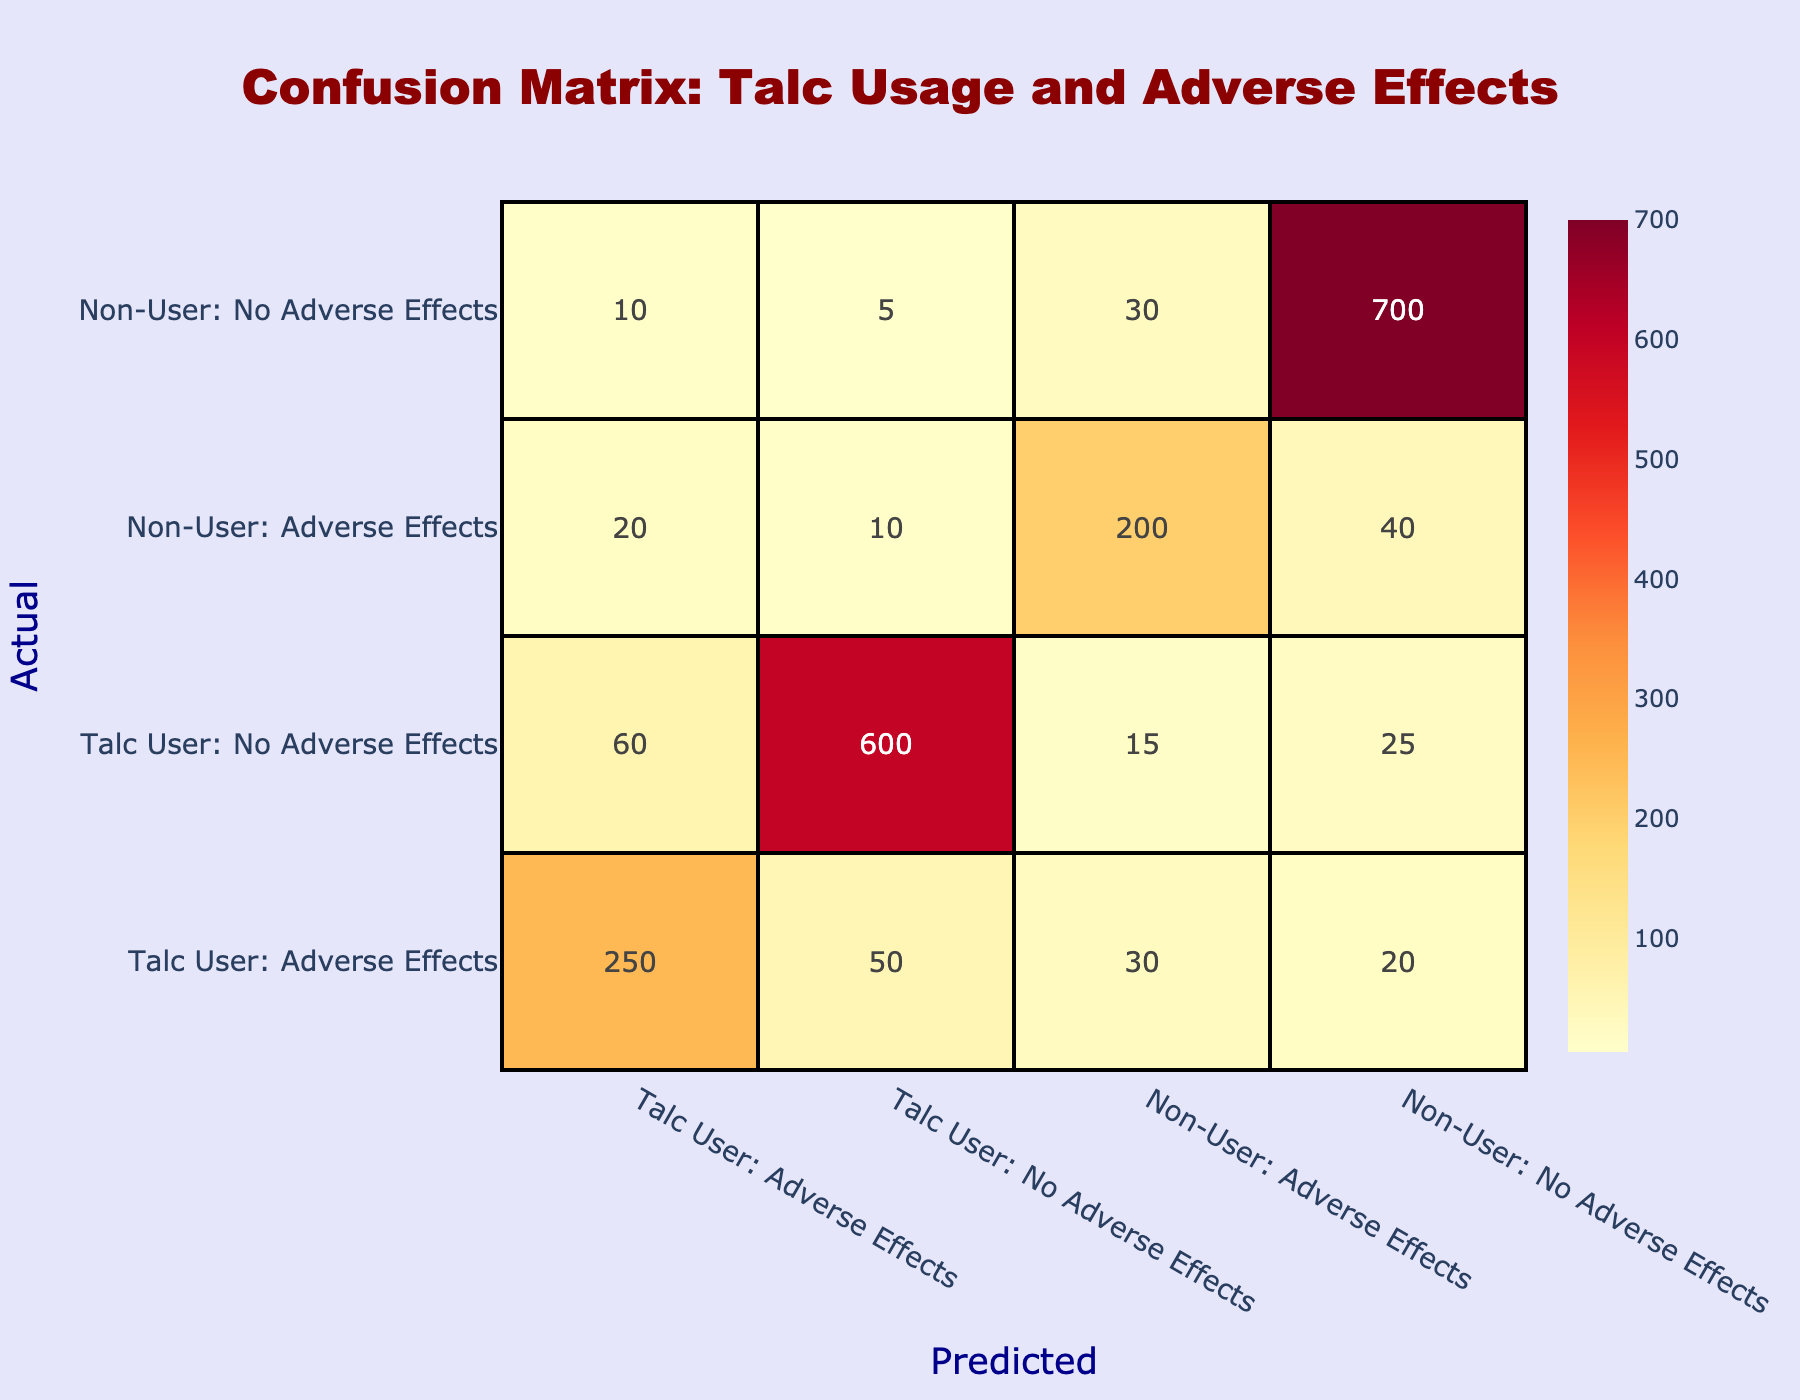What is the total number of Talc Users who reported Adverse Effects? From the table, we can see the value under "Talc User: Adverse Effects" is 250. This value represents the total number of Talc Users who reported Adverse Effects, directly taken from the table.
Answer: 250 How many Non-Users reported Adverse Effects according to the table? The table shows that under "Non-User: Adverse Effects," the value is 200, indicating the total number of Non-Users who reported Adverse Effects. This value is directly read from the table.
Answer: 200 What is the difference in the number of Talc Users with Adverse Effects versus Non-Users with Adverse Effects? To find the difference, we subtract the number of Non-Users with Adverse Effects (200) from the number of Talc Users with Adverse Effects (250): 250 - 200 = 50. So the difference is 50.
Answer: 50 How many individuals did not report Adverse Effects among Talc Users? The table indicates that under "Talc User: No Adverse Effects," there are 600 individuals who did not report any Adverse Effects. This value can be directly accessed from the table.
Answer: 600 Is it true that more Talc Users reported Adverse Effects than Non-Users? Yes, it is true. From the table, Talc Users reported 250 Adverse Effects while Non-Users reported 200 Adverse Effects, confirming that Talc Users have a higher count.
Answer: Yes What is the total number of individuals who reported Adverse Effects (both Users and Non-Users)? To find the total, we need to sum up the reported Adverse Effects: (250 from Talc Users + 200 from Non-Users) which equals 450. This total is calculated by adding the two values.
Answer: 450 How many individuals did not report Adverse Effects among Non-Users? The table shows that there are 700 individuals under "Non-User: No Adverse Effects," which represents the number of Non-Users who did not report any Adverse Effects. This number is read directly from the table.
Answer: 700 Which group has a higher number of individuals reporting Adverse Effects: Talc Users or Non-Users? Talc Users has 250 individuals reporting Adverse Effects, whereas Non-Users have 200. Thus, Talc Users have a higher number of reported Adverse Effects.
Answer: Talc Users What is the total number of individuals in the Talc User group (both Adverse Effects and No Adverse Effects)? We calculate the total for Talc Users by summing both categories: 250 (Adverse Effects) + 600 (No Adverse Effects) equals 850. This total gives us the complete count of individuals in the Talc User group.
Answer: 850 